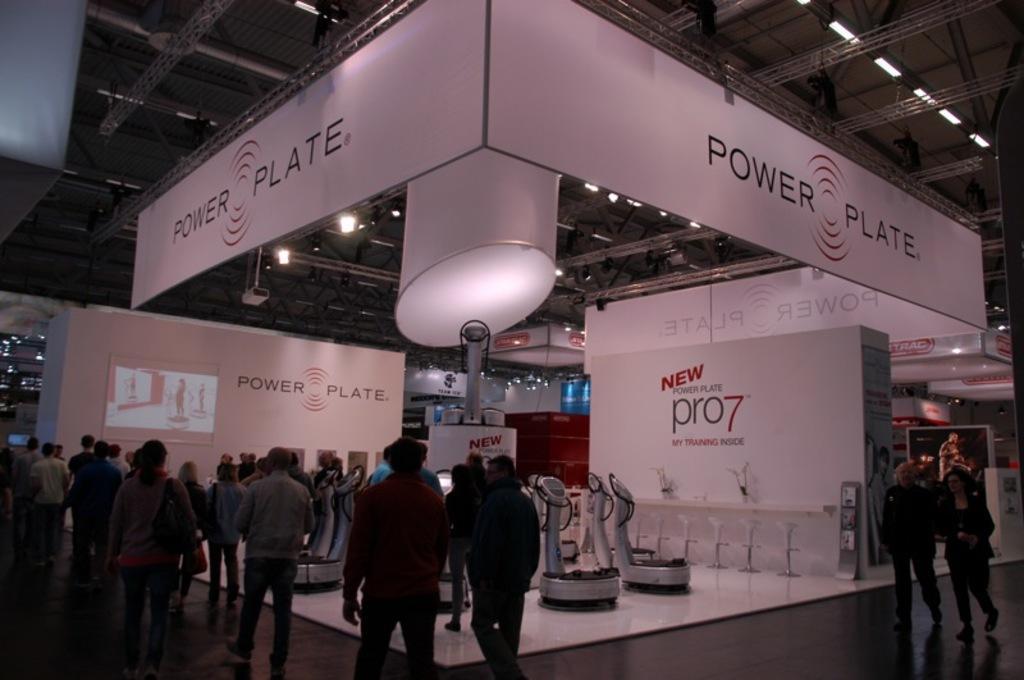Can you describe this image briefly? Here in this picture we can see number of people standing and walking on the floor over there and in the middle we can see some machines present and we can see banners present on the floor and hanging on the roof over there and in the middle we can see a light present and we can see other lights also present on the roof over there. 